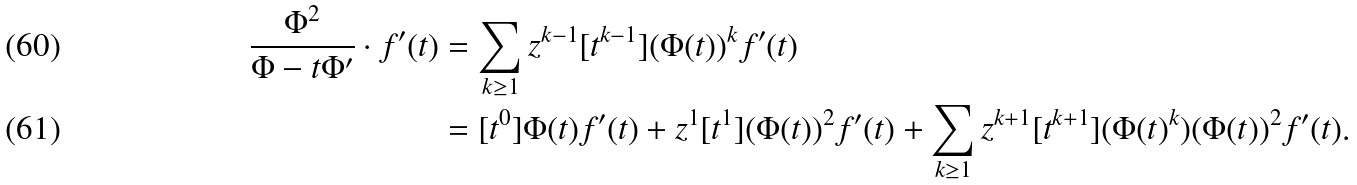<formula> <loc_0><loc_0><loc_500><loc_500>\frac { \Phi ^ { 2 } } { \Phi - t \Phi ^ { \prime } } \cdot f ^ { \prime } ( t ) & = \sum _ { k \geq 1 } z ^ { k - 1 } [ t ^ { k - 1 } ] ( \Phi ( t ) ) ^ { k } f ^ { \prime } ( t ) \\ & = [ t ^ { 0 } ] \Phi ( t ) f ^ { \prime } ( t ) + z ^ { 1 } [ t ^ { 1 } ] ( \Phi ( t ) ) ^ { 2 } f ^ { \prime } ( t ) + \sum _ { k \geq 1 } z ^ { k + 1 } [ t ^ { k + 1 } ] ( \Phi ( t ) ^ { k } ) ( \Phi ( t ) ) ^ { 2 } f ^ { \prime } ( t ) .</formula> 